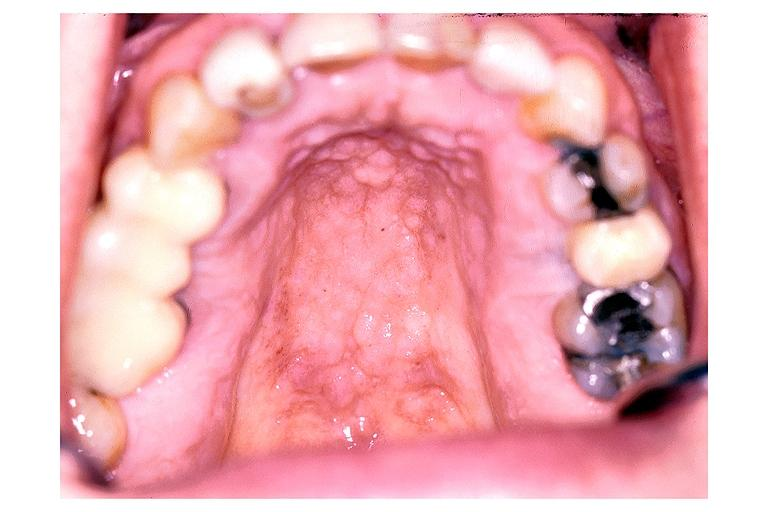does lupus erythematosus periarterial fibrosis show inflamatory papillary hyperplasia?
Answer the question using a single word or phrase. No 